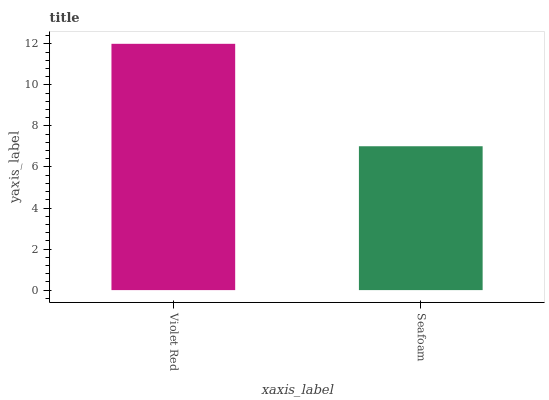Is Seafoam the maximum?
Answer yes or no. No. Is Violet Red greater than Seafoam?
Answer yes or no. Yes. Is Seafoam less than Violet Red?
Answer yes or no. Yes. Is Seafoam greater than Violet Red?
Answer yes or no. No. Is Violet Red less than Seafoam?
Answer yes or no. No. Is Violet Red the high median?
Answer yes or no. Yes. Is Seafoam the low median?
Answer yes or no. Yes. Is Seafoam the high median?
Answer yes or no. No. Is Violet Red the low median?
Answer yes or no. No. 